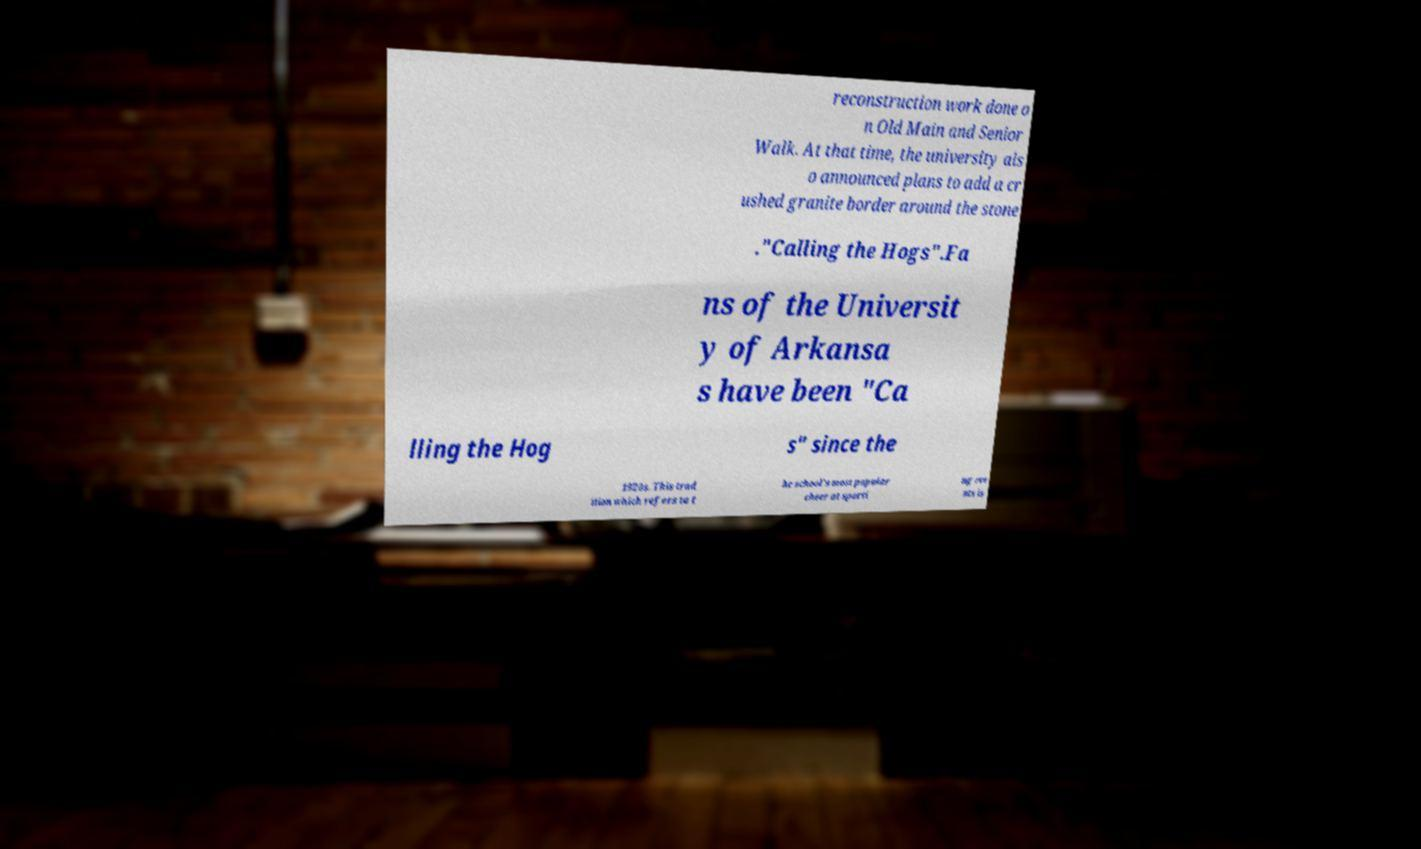I need the written content from this picture converted into text. Can you do that? reconstruction work done o n Old Main and Senior Walk. At that time, the university als o announced plans to add a cr ushed granite border around the stone ."Calling the Hogs".Fa ns of the Universit y of Arkansa s have been "Ca lling the Hog s" since the 1920s. This trad ition which refers to t he school's most popular cheer at sporti ng eve nts is 